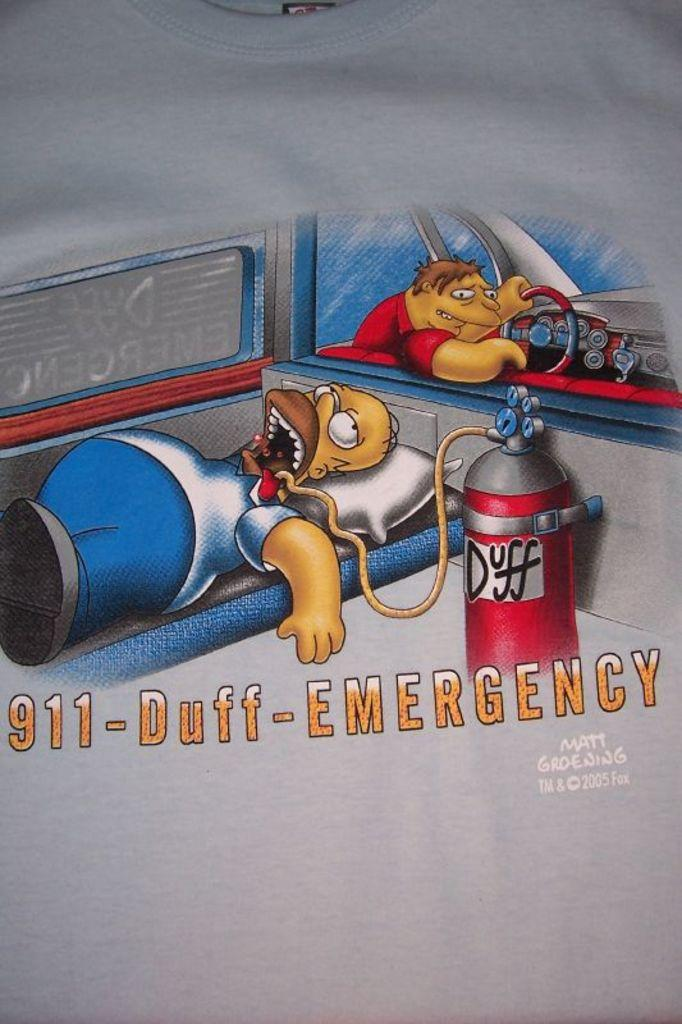<image>
Render a clear and concise summary of the photo. A cartoon of Homer Simpson with the message 911-Duff-Emergency 